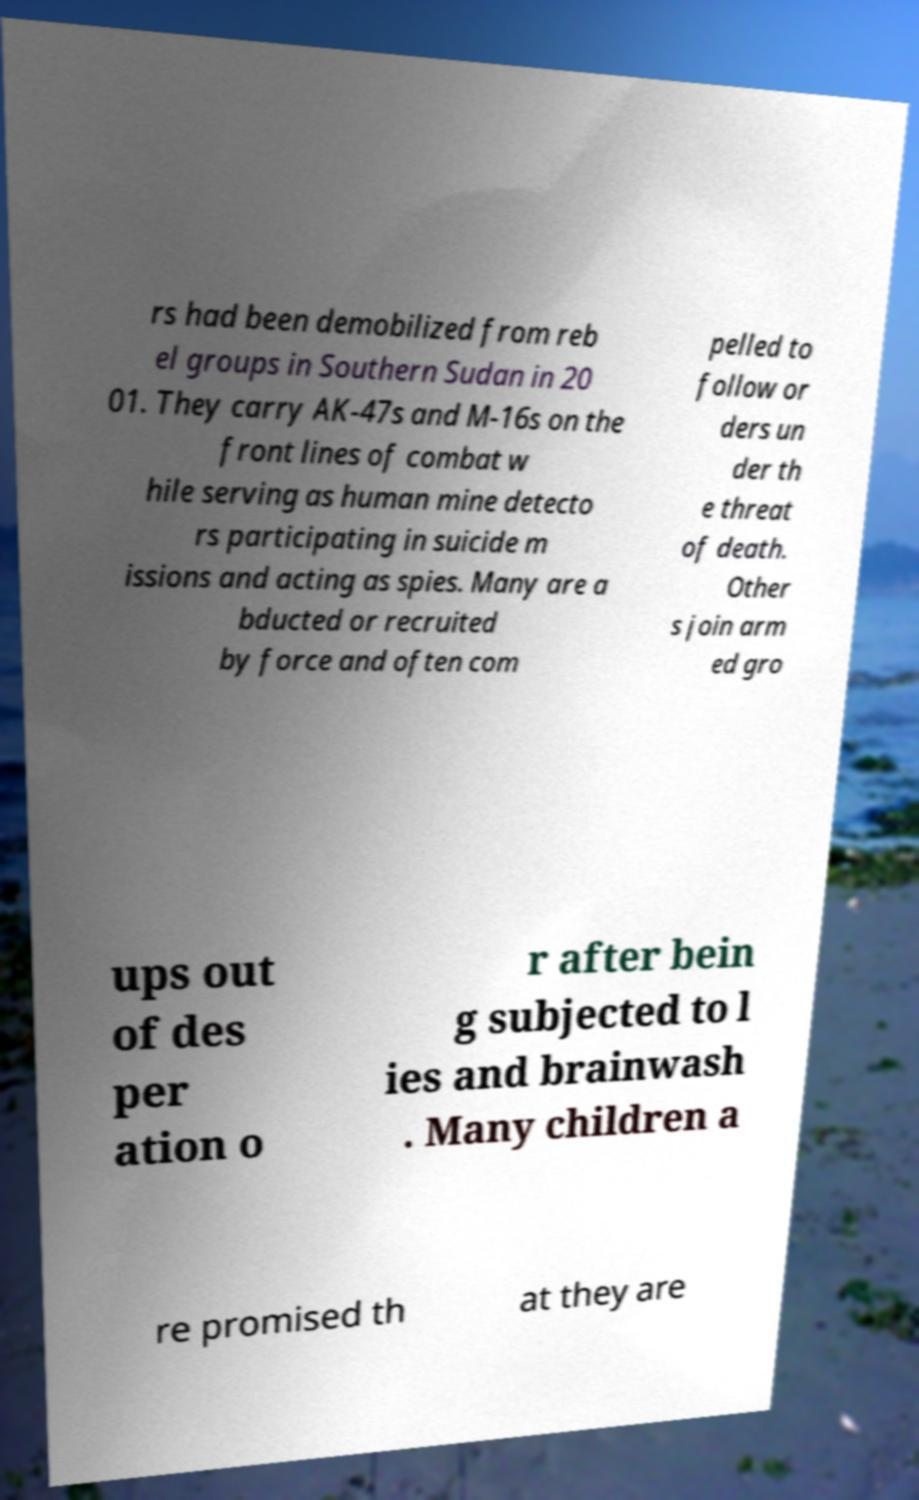There's text embedded in this image that I need extracted. Can you transcribe it verbatim? rs had been demobilized from reb el groups in Southern Sudan in 20 01. They carry AK-47s and M-16s on the front lines of combat w hile serving as human mine detecto rs participating in suicide m issions and acting as spies. Many are a bducted or recruited by force and often com pelled to follow or ders un der th e threat of death. Other s join arm ed gro ups out of des per ation o r after bein g subjected to l ies and brainwash . Many children a re promised th at they are 